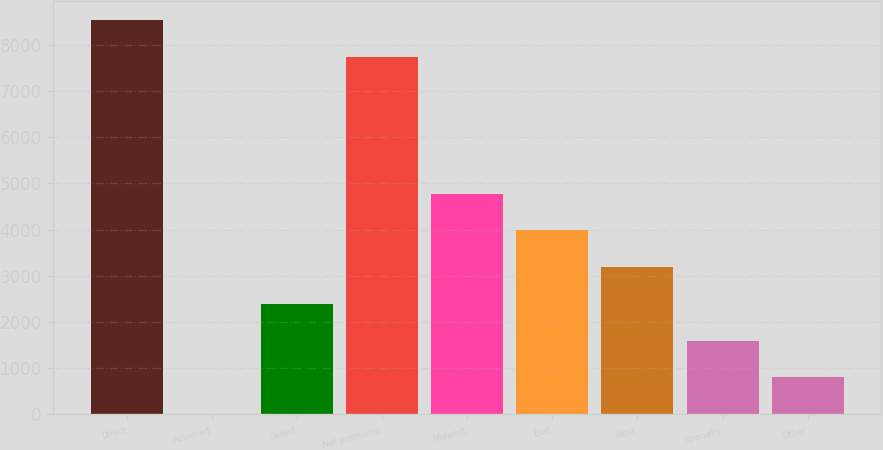Convert chart. <chart><loc_0><loc_0><loc_500><loc_500><bar_chart><fcel>Direct<fcel>Assumed<fcel>Ceded<fcel>Net premiums<fcel>Midwest<fcel>East<fcel>West<fcel>Specialty<fcel>Other<nl><fcel>8533.26<fcel>1.9<fcel>2389.78<fcel>7737.3<fcel>4777.66<fcel>3981.7<fcel>3185.74<fcel>1593.82<fcel>797.86<nl></chart> 